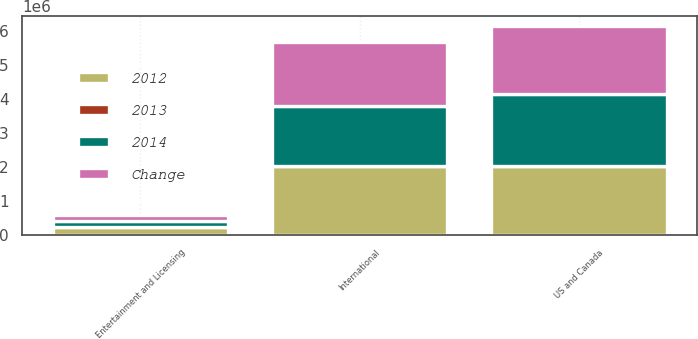Convert chart. <chart><loc_0><loc_0><loc_500><loc_500><stacked_bar_chart><ecel><fcel>US and Canada<fcel>International<fcel>Entertainment and Licensing<nl><fcel>2012<fcel>2.02244e+06<fcel>2.023e+06<fcel>219465<nl><fcel>2013<fcel>1<fcel>8<fcel>15<nl><fcel>Change<fcel>2.00608e+06<fcel>1.87298e+06<fcel>190955<nl><fcel>2014<fcel>2.1163e+06<fcel>1.78212e+06<fcel>181430<nl></chart> 